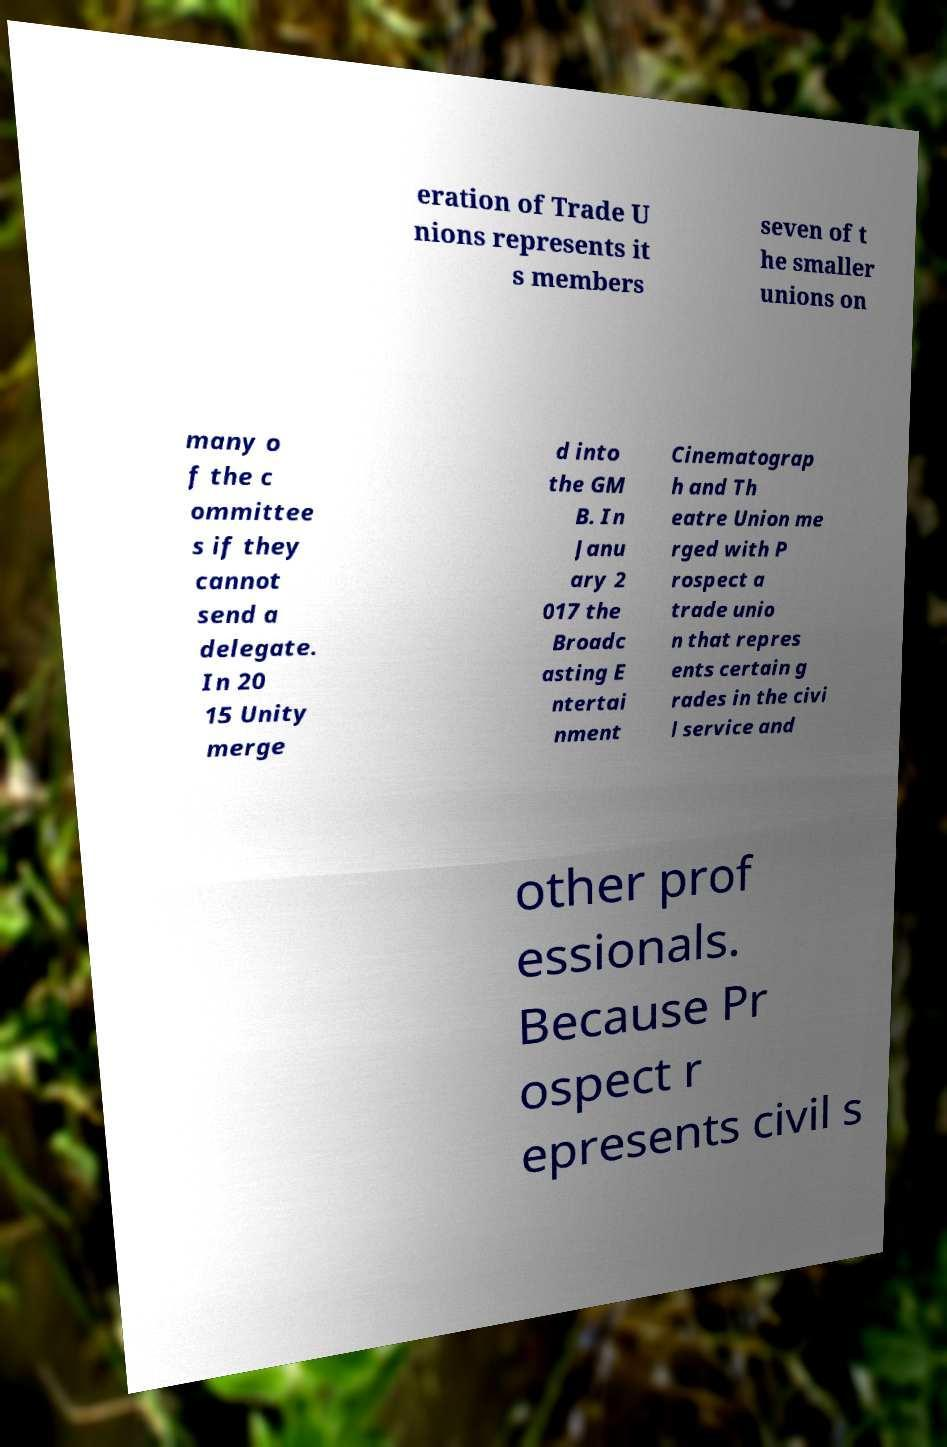What messages or text are displayed in this image? I need them in a readable, typed format. eration of Trade U nions represents it s members seven of t he smaller unions on many o f the c ommittee s if they cannot send a delegate. In 20 15 Unity merge d into the GM B. In Janu ary 2 017 the Broadc asting E ntertai nment Cinematograp h and Th eatre Union me rged with P rospect a trade unio n that repres ents certain g rades in the civi l service and other prof essionals. Because Pr ospect r epresents civil s 